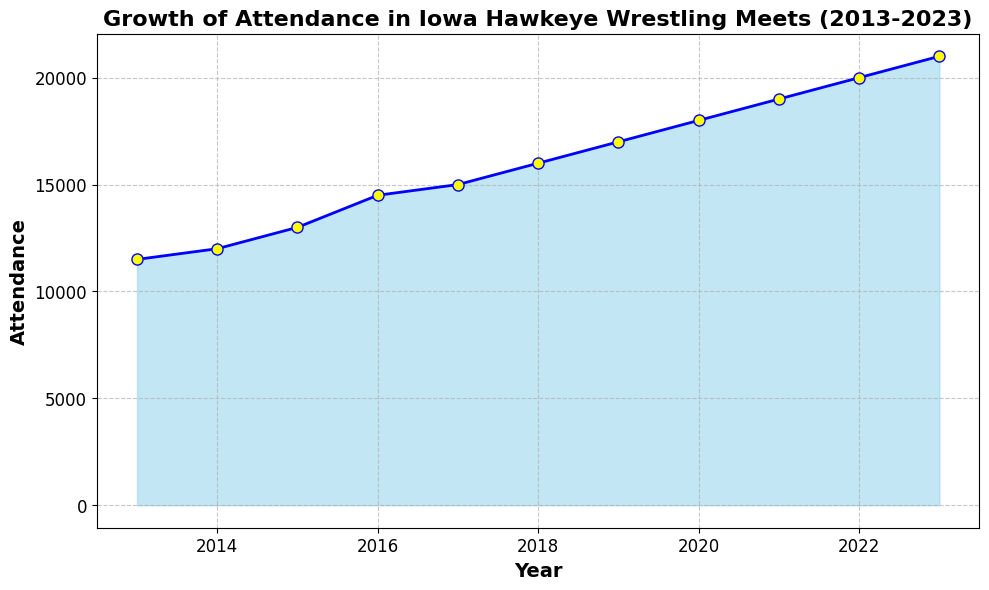What's the total attendance over the decade? To find the total attendance, sum up the attendance values from each year: 11500 + 12000 + 13000 + 14500 + 15000 + 16000 + 17000 + 18000 + 19000 + 20000 + 21000 = 187000
Answer: 187000 Which year saw the highest attendance? To find the highest attendance, refer to the plot and identify the year with the peak value. The highest point is at year 2023 with an attendance of 21000.
Answer: 2023 How much did the attendance increase from 2013 to 2023? Subtract the attendance value of 2013 from the attendance value of 2023, which is 21000 - 11500 = 9500
Answer: 9500 What is the average attendance over the years shown? Sum the total attendance over the decade and then divide by the number of years. The sum is 187000 and there are 11 years, hence 187000/11 = 17000
Answer: 17000 Between which consecutive years was the largest increase in attendance observed? Calculate the difference in attendance between each consecutive year and find the maximum increase. The differences are 500, 1000, 1500, 500, 1000, 1000, 1000, 1000, 1000, 1000. The largest increase of 1500 was observed between 2015 and 2016
Answer: 2015-2016 What is the trend of the attendance growth over the years? Look at the general direction of the slope in the plot. The attendance values steadily increase over each year, showing an upward trend.
Answer: Upward Which years had attendances above the average attendance? The average attendance is 17000. Identify the years with attendances above this average: 2019, 2020, 2021, 2022, and 2023, with attendances of 17000, 18000, 19000, 20000, and 21000 respectively
Answer: 2019, 2020, 2021, 2022, 2023 What percentage increase in attendance is observed from 2013 to 2023? Calculate the percentage increase using (New Value - Old Value) / Old Value * 100. The new value is 21000, old value is 11500. ((21000 - 11500) / 11500) * 100 = 82.6%
Answer: 82.6% Between which years did the attendance change the least? Find the pair of consecutive years with the smallest difference in attendance. The differences between the years are: 500, 1000, 1500, 500, 1000, 1000, 1000, 1000, 1000, 1000. The smallest change of 500 was observed between 2013-2014 and 2016-2017
Answer: 2013-2014, 2016-2017 